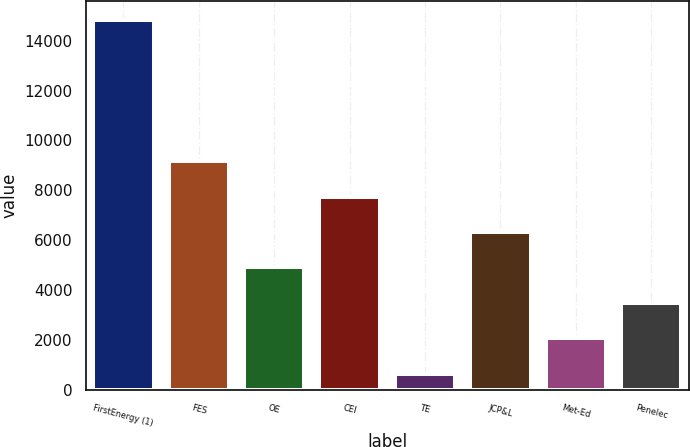<chart> <loc_0><loc_0><loc_500><loc_500><bar_chart><fcel>FirstEnergy (1)<fcel>FES<fcel>OE<fcel>CEI<fcel>TE<fcel>JCP&L<fcel>Met-Ed<fcel>Penelec<nl><fcel>14845<fcel>9168.2<fcel>4910.6<fcel>7749<fcel>653<fcel>6329.8<fcel>2072.2<fcel>3491.4<nl></chart> 